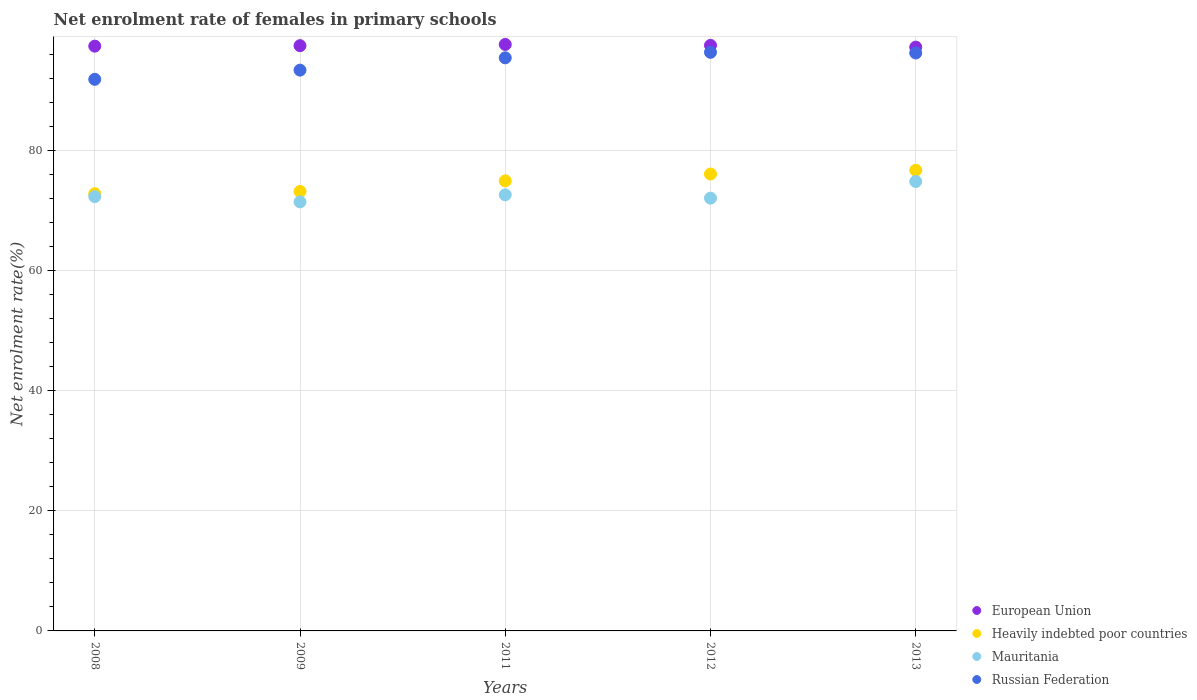How many different coloured dotlines are there?
Provide a short and direct response. 4. Is the number of dotlines equal to the number of legend labels?
Your response must be concise. Yes. What is the net enrolment rate of females in primary schools in Russian Federation in 2011?
Your answer should be very brief. 95.47. Across all years, what is the maximum net enrolment rate of females in primary schools in European Union?
Offer a terse response. 97.7. Across all years, what is the minimum net enrolment rate of females in primary schools in Mauritania?
Offer a very short reply. 71.47. In which year was the net enrolment rate of females in primary schools in European Union maximum?
Keep it short and to the point. 2011. In which year was the net enrolment rate of females in primary schools in Russian Federation minimum?
Your answer should be compact. 2008. What is the total net enrolment rate of females in primary schools in Heavily indebted poor countries in the graph?
Provide a succinct answer. 373.87. What is the difference between the net enrolment rate of females in primary schools in Russian Federation in 2009 and that in 2011?
Offer a very short reply. -2.05. What is the difference between the net enrolment rate of females in primary schools in Mauritania in 2011 and the net enrolment rate of females in primary schools in European Union in 2013?
Make the answer very short. -24.61. What is the average net enrolment rate of females in primary schools in Mauritania per year?
Offer a very short reply. 72.68. In the year 2013, what is the difference between the net enrolment rate of females in primary schools in European Union and net enrolment rate of females in primary schools in Heavily indebted poor countries?
Provide a succinct answer. 20.51. In how many years, is the net enrolment rate of females in primary schools in Mauritania greater than 8 %?
Give a very brief answer. 5. What is the ratio of the net enrolment rate of females in primary schools in Mauritania in 2011 to that in 2013?
Keep it short and to the point. 0.97. Is the difference between the net enrolment rate of females in primary schools in European Union in 2011 and 2012 greater than the difference between the net enrolment rate of females in primary schools in Heavily indebted poor countries in 2011 and 2012?
Your response must be concise. Yes. What is the difference between the highest and the second highest net enrolment rate of females in primary schools in Mauritania?
Provide a succinct answer. 2.22. What is the difference between the highest and the lowest net enrolment rate of females in primary schools in European Union?
Keep it short and to the point. 0.44. Is it the case that in every year, the sum of the net enrolment rate of females in primary schools in Heavily indebted poor countries and net enrolment rate of females in primary schools in European Union  is greater than the sum of net enrolment rate of females in primary schools in Russian Federation and net enrolment rate of females in primary schools in Mauritania?
Provide a short and direct response. Yes. Is it the case that in every year, the sum of the net enrolment rate of females in primary schools in Mauritania and net enrolment rate of females in primary schools in Heavily indebted poor countries  is greater than the net enrolment rate of females in primary schools in Russian Federation?
Provide a short and direct response. Yes. Is the net enrolment rate of females in primary schools in Mauritania strictly greater than the net enrolment rate of females in primary schools in Russian Federation over the years?
Your response must be concise. No. How many dotlines are there?
Your answer should be very brief. 4. What is the difference between two consecutive major ticks on the Y-axis?
Keep it short and to the point. 20. How many legend labels are there?
Your answer should be compact. 4. How are the legend labels stacked?
Your answer should be compact. Vertical. What is the title of the graph?
Your answer should be compact. Net enrolment rate of females in primary schools. Does "Switzerland" appear as one of the legend labels in the graph?
Offer a very short reply. No. What is the label or title of the Y-axis?
Provide a short and direct response. Net enrolment rate(%). What is the Net enrolment rate(%) in European Union in 2008?
Your response must be concise. 97.41. What is the Net enrolment rate(%) in Heavily indebted poor countries in 2008?
Provide a succinct answer. 72.83. What is the Net enrolment rate(%) in Mauritania in 2008?
Your answer should be compact. 72.34. What is the Net enrolment rate(%) in Russian Federation in 2008?
Give a very brief answer. 91.89. What is the Net enrolment rate(%) in European Union in 2009?
Your answer should be compact. 97.49. What is the Net enrolment rate(%) in Heavily indebted poor countries in 2009?
Give a very brief answer. 73.21. What is the Net enrolment rate(%) in Mauritania in 2009?
Make the answer very short. 71.47. What is the Net enrolment rate(%) in Russian Federation in 2009?
Your answer should be compact. 93.42. What is the Net enrolment rate(%) of European Union in 2011?
Offer a very short reply. 97.7. What is the Net enrolment rate(%) in Heavily indebted poor countries in 2011?
Offer a very short reply. 74.97. What is the Net enrolment rate(%) in Mauritania in 2011?
Provide a short and direct response. 72.65. What is the Net enrolment rate(%) of Russian Federation in 2011?
Provide a short and direct response. 95.47. What is the Net enrolment rate(%) of European Union in 2012?
Your answer should be compact. 97.54. What is the Net enrolment rate(%) of Heavily indebted poor countries in 2012?
Keep it short and to the point. 76.11. What is the Net enrolment rate(%) of Mauritania in 2012?
Provide a short and direct response. 72.09. What is the Net enrolment rate(%) in Russian Federation in 2012?
Make the answer very short. 96.38. What is the Net enrolment rate(%) in European Union in 2013?
Give a very brief answer. 97.25. What is the Net enrolment rate(%) in Heavily indebted poor countries in 2013?
Give a very brief answer. 76.74. What is the Net enrolment rate(%) of Mauritania in 2013?
Make the answer very short. 74.87. What is the Net enrolment rate(%) of Russian Federation in 2013?
Keep it short and to the point. 96.27. Across all years, what is the maximum Net enrolment rate(%) of European Union?
Make the answer very short. 97.7. Across all years, what is the maximum Net enrolment rate(%) of Heavily indebted poor countries?
Offer a very short reply. 76.74. Across all years, what is the maximum Net enrolment rate(%) of Mauritania?
Your answer should be compact. 74.87. Across all years, what is the maximum Net enrolment rate(%) of Russian Federation?
Offer a terse response. 96.38. Across all years, what is the minimum Net enrolment rate(%) of European Union?
Your answer should be compact. 97.25. Across all years, what is the minimum Net enrolment rate(%) of Heavily indebted poor countries?
Make the answer very short. 72.83. Across all years, what is the minimum Net enrolment rate(%) of Mauritania?
Your answer should be very brief. 71.47. Across all years, what is the minimum Net enrolment rate(%) in Russian Federation?
Offer a very short reply. 91.89. What is the total Net enrolment rate(%) of European Union in the graph?
Your answer should be very brief. 487.4. What is the total Net enrolment rate(%) in Heavily indebted poor countries in the graph?
Provide a short and direct response. 373.87. What is the total Net enrolment rate(%) of Mauritania in the graph?
Keep it short and to the point. 363.42. What is the total Net enrolment rate(%) in Russian Federation in the graph?
Offer a terse response. 473.43. What is the difference between the Net enrolment rate(%) in European Union in 2008 and that in 2009?
Your answer should be compact. -0.08. What is the difference between the Net enrolment rate(%) in Heavily indebted poor countries in 2008 and that in 2009?
Provide a succinct answer. -0.37. What is the difference between the Net enrolment rate(%) in Mauritania in 2008 and that in 2009?
Offer a very short reply. 0.87. What is the difference between the Net enrolment rate(%) in Russian Federation in 2008 and that in 2009?
Provide a short and direct response. -1.53. What is the difference between the Net enrolment rate(%) in European Union in 2008 and that in 2011?
Provide a short and direct response. -0.28. What is the difference between the Net enrolment rate(%) of Heavily indebted poor countries in 2008 and that in 2011?
Provide a short and direct response. -2.14. What is the difference between the Net enrolment rate(%) of Mauritania in 2008 and that in 2011?
Your answer should be compact. -0.3. What is the difference between the Net enrolment rate(%) of Russian Federation in 2008 and that in 2011?
Make the answer very short. -3.58. What is the difference between the Net enrolment rate(%) of European Union in 2008 and that in 2012?
Make the answer very short. -0.13. What is the difference between the Net enrolment rate(%) in Heavily indebted poor countries in 2008 and that in 2012?
Offer a terse response. -3.28. What is the difference between the Net enrolment rate(%) in Mauritania in 2008 and that in 2012?
Offer a very short reply. 0.26. What is the difference between the Net enrolment rate(%) in Russian Federation in 2008 and that in 2012?
Your answer should be very brief. -4.5. What is the difference between the Net enrolment rate(%) in European Union in 2008 and that in 2013?
Your answer should be compact. 0.16. What is the difference between the Net enrolment rate(%) in Heavily indebted poor countries in 2008 and that in 2013?
Make the answer very short. -3.91. What is the difference between the Net enrolment rate(%) of Mauritania in 2008 and that in 2013?
Keep it short and to the point. -2.52. What is the difference between the Net enrolment rate(%) in Russian Federation in 2008 and that in 2013?
Provide a short and direct response. -4.38. What is the difference between the Net enrolment rate(%) in European Union in 2009 and that in 2011?
Your answer should be very brief. -0.2. What is the difference between the Net enrolment rate(%) of Heavily indebted poor countries in 2009 and that in 2011?
Your answer should be compact. -1.76. What is the difference between the Net enrolment rate(%) in Mauritania in 2009 and that in 2011?
Make the answer very short. -1.18. What is the difference between the Net enrolment rate(%) of Russian Federation in 2009 and that in 2011?
Your response must be concise. -2.05. What is the difference between the Net enrolment rate(%) in European Union in 2009 and that in 2012?
Make the answer very short. -0.05. What is the difference between the Net enrolment rate(%) of Heavily indebted poor countries in 2009 and that in 2012?
Your response must be concise. -2.91. What is the difference between the Net enrolment rate(%) in Mauritania in 2009 and that in 2012?
Your answer should be compact. -0.62. What is the difference between the Net enrolment rate(%) in Russian Federation in 2009 and that in 2012?
Your answer should be compact. -2.97. What is the difference between the Net enrolment rate(%) in European Union in 2009 and that in 2013?
Keep it short and to the point. 0.24. What is the difference between the Net enrolment rate(%) in Heavily indebted poor countries in 2009 and that in 2013?
Ensure brevity in your answer.  -3.53. What is the difference between the Net enrolment rate(%) in Mauritania in 2009 and that in 2013?
Offer a very short reply. -3.4. What is the difference between the Net enrolment rate(%) in Russian Federation in 2009 and that in 2013?
Provide a succinct answer. -2.85. What is the difference between the Net enrolment rate(%) of European Union in 2011 and that in 2012?
Give a very brief answer. 0.15. What is the difference between the Net enrolment rate(%) of Heavily indebted poor countries in 2011 and that in 2012?
Offer a very short reply. -1.14. What is the difference between the Net enrolment rate(%) of Mauritania in 2011 and that in 2012?
Ensure brevity in your answer.  0.56. What is the difference between the Net enrolment rate(%) of Russian Federation in 2011 and that in 2012?
Make the answer very short. -0.92. What is the difference between the Net enrolment rate(%) of European Union in 2011 and that in 2013?
Offer a terse response. 0.44. What is the difference between the Net enrolment rate(%) of Heavily indebted poor countries in 2011 and that in 2013?
Your answer should be very brief. -1.77. What is the difference between the Net enrolment rate(%) in Mauritania in 2011 and that in 2013?
Keep it short and to the point. -2.22. What is the difference between the Net enrolment rate(%) in Russian Federation in 2011 and that in 2013?
Your answer should be very brief. -0.8. What is the difference between the Net enrolment rate(%) of European Union in 2012 and that in 2013?
Provide a succinct answer. 0.29. What is the difference between the Net enrolment rate(%) of Heavily indebted poor countries in 2012 and that in 2013?
Keep it short and to the point. -0.63. What is the difference between the Net enrolment rate(%) of Mauritania in 2012 and that in 2013?
Ensure brevity in your answer.  -2.78. What is the difference between the Net enrolment rate(%) in Russian Federation in 2012 and that in 2013?
Provide a succinct answer. 0.11. What is the difference between the Net enrolment rate(%) in European Union in 2008 and the Net enrolment rate(%) in Heavily indebted poor countries in 2009?
Offer a very short reply. 24.21. What is the difference between the Net enrolment rate(%) of European Union in 2008 and the Net enrolment rate(%) of Mauritania in 2009?
Your answer should be compact. 25.94. What is the difference between the Net enrolment rate(%) of European Union in 2008 and the Net enrolment rate(%) of Russian Federation in 2009?
Give a very brief answer. 4. What is the difference between the Net enrolment rate(%) of Heavily indebted poor countries in 2008 and the Net enrolment rate(%) of Mauritania in 2009?
Ensure brevity in your answer.  1.36. What is the difference between the Net enrolment rate(%) of Heavily indebted poor countries in 2008 and the Net enrolment rate(%) of Russian Federation in 2009?
Make the answer very short. -20.59. What is the difference between the Net enrolment rate(%) in Mauritania in 2008 and the Net enrolment rate(%) in Russian Federation in 2009?
Your response must be concise. -21.07. What is the difference between the Net enrolment rate(%) of European Union in 2008 and the Net enrolment rate(%) of Heavily indebted poor countries in 2011?
Your answer should be very brief. 22.45. What is the difference between the Net enrolment rate(%) in European Union in 2008 and the Net enrolment rate(%) in Mauritania in 2011?
Offer a terse response. 24.77. What is the difference between the Net enrolment rate(%) in European Union in 2008 and the Net enrolment rate(%) in Russian Federation in 2011?
Give a very brief answer. 1.95. What is the difference between the Net enrolment rate(%) in Heavily indebted poor countries in 2008 and the Net enrolment rate(%) in Mauritania in 2011?
Make the answer very short. 0.19. What is the difference between the Net enrolment rate(%) in Heavily indebted poor countries in 2008 and the Net enrolment rate(%) in Russian Federation in 2011?
Provide a succinct answer. -22.63. What is the difference between the Net enrolment rate(%) in Mauritania in 2008 and the Net enrolment rate(%) in Russian Federation in 2011?
Provide a short and direct response. -23.12. What is the difference between the Net enrolment rate(%) in European Union in 2008 and the Net enrolment rate(%) in Heavily indebted poor countries in 2012?
Give a very brief answer. 21.3. What is the difference between the Net enrolment rate(%) in European Union in 2008 and the Net enrolment rate(%) in Mauritania in 2012?
Your response must be concise. 25.33. What is the difference between the Net enrolment rate(%) of European Union in 2008 and the Net enrolment rate(%) of Russian Federation in 2012?
Ensure brevity in your answer.  1.03. What is the difference between the Net enrolment rate(%) in Heavily indebted poor countries in 2008 and the Net enrolment rate(%) in Mauritania in 2012?
Your response must be concise. 0.74. What is the difference between the Net enrolment rate(%) of Heavily indebted poor countries in 2008 and the Net enrolment rate(%) of Russian Federation in 2012?
Make the answer very short. -23.55. What is the difference between the Net enrolment rate(%) in Mauritania in 2008 and the Net enrolment rate(%) in Russian Federation in 2012?
Give a very brief answer. -24.04. What is the difference between the Net enrolment rate(%) in European Union in 2008 and the Net enrolment rate(%) in Heavily indebted poor countries in 2013?
Provide a succinct answer. 20.67. What is the difference between the Net enrolment rate(%) in European Union in 2008 and the Net enrolment rate(%) in Mauritania in 2013?
Offer a very short reply. 22.55. What is the difference between the Net enrolment rate(%) in European Union in 2008 and the Net enrolment rate(%) in Russian Federation in 2013?
Your answer should be compact. 1.14. What is the difference between the Net enrolment rate(%) in Heavily indebted poor countries in 2008 and the Net enrolment rate(%) in Mauritania in 2013?
Keep it short and to the point. -2.03. What is the difference between the Net enrolment rate(%) in Heavily indebted poor countries in 2008 and the Net enrolment rate(%) in Russian Federation in 2013?
Provide a succinct answer. -23.44. What is the difference between the Net enrolment rate(%) in Mauritania in 2008 and the Net enrolment rate(%) in Russian Federation in 2013?
Make the answer very short. -23.93. What is the difference between the Net enrolment rate(%) of European Union in 2009 and the Net enrolment rate(%) of Heavily indebted poor countries in 2011?
Provide a short and direct response. 22.52. What is the difference between the Net enrolment rate(%) in European Union in 2009 and the Net enrolment rate(%) in Mauritania in 2011?
Your answer should be very brief. 24.85. What is the difference between the Net enrolment rate(%) in European Union in 2009 and the Net enrolment rate(%) in Russian Federation in 2011?
Make the answer very short. 2.03. What is the difference between the Net enrolment rate(%) in Heavily indebted poor countries in 2009 and the Net enrolment rate(%) in Mauritania in 2011?
Your answer should be compact. 0.56. What is the difference between the Net enrolment rate(%) of Heavily indebted poor countries in 2009 and the Net enrolment rate(%) of Russian Federation in 2011?
Your answer should be compact. -22.26. What is the difference between the Net enrolment rate(%) of Mauritania in 2009 and the Net enrolment rate(%) of Russian Federation in 2011?
Ensure brevity in your answer.  -24. What is the difference between the Net enrolment rate(%) of European Union in 2009 and the Net enrolment rate(%) of Heavily indebted poor countries in 2012?
Your response must be concise. 21.38. What is the difference between the Net enrolment rate(%) in European Union in 2009 and the Net enrolment rate(%) in Mauritania in 2012?
Give a very brief answer. 25.4. What is the difference between the Net enrolment rate(%) in European Union in 2009 and the Net enrolment rate(%) in Russian Federation in 2012?
Keep it short and to the point. 1.11. What is the difference between the Net enrolment rate(%) of Heavily indebted poor countries in 2009 and the Net enrolment rate(%) of Mauritania in 2012?
Your response must be concise. 1.12. What is the difference between the Net enrolment rate(%) in Heavily indebted poor countries in 2009 and the Net enrolment rate(%) in Russian Federation in 2012?
Give a very brief answer. -23.18. What is the difference between the Net enrolment rate(%) of Mauritania in 2009 and the Net enrolment rate(%) of Russian Federation in 2012?
Your response must be concise. -24.91. What is the difference between the Net enrolment rate(%) of European Union in 2009 and the Net enrolment rate(%) of Heavily indebted poor countries in 2013?
Your answer should be very brief. 20.75. What is the difference between the Net enrolment rate(%) of European Union in 2009 and the Net enrolment rate(%) of Mauritania in 2013?
Provide a short and direct response. 22.63. What is the difference between the Net enrolment rate(%) in European Union in 2009 and the Net enrolment rate(%) in Russian Federation in 2013?
Your response must be concise. 1.22. What is the difference between the Net enrolment rate(%) in Heavily indebted poor countries in 2009 and the Net enrolment rate(%) in Mauritania in 2013?
Your answer should be very brief. -1.66. What is the difference between the Net enrolment rate(%) in Heavily indebted poor countries in 2009 and the Net enrolment rate(%) in Russian Federation in 2013?
Your answer should be compact. -23.06. What is the difference between the Net enrolment rate(%) of Mauritania in 2009 and the Net enrolment rate(%) of Russian Federation in 2013?
Offer a terse response. -24.8. What is the difference between the Net enrolment rate(%) of European Union in 2011 and the Net enrolment rate(%) of Heavily indebted poor countries in 2012?
Make the answer very short. 21.58. What is the difference between the Net enrolment rate(%) in European Union in 2011 and the Net enrolment rate(%) in Mauritania in 2012?
Offer a very short reply. 25.61. What is the difference between the Net enrolment rate(%) in European Union in 2011 and the Net enrolment rate(%) in Russian Federation in 2012?
Offer a terse response. 1.31. What is the difference between the Net enrolment rate(%) of Heavily indebted poor countries in 2011 and the Net enrolment rate(%) of Mauritania in 2012?
Keep it short and to the point. 2.88. What is the difference between the Net enrolment rate(%) in Heavily indebted poor countries in 2011 and the Net enrolment rate(%) in Russian Federation in 2012?
Your answer should be compact. -21.41. What is the difference between the Net enrolment rate(%) of Mauritania in 2011 and the Net enrolment rate(%) of Russian Federation in 2012?
Your response must be concise. -23.74. What is the difference between the Net enrolment rate(%) of European Union in 2011 and the Net enrolment rate(%) of Heavily indebted poor countries in 2013?
Ensure brevity in your answer.  20.96. What is the difference between the Net enrolment rate(%) in European Union in 2011 and the Net enrolment rate(%) in Mauritania in 2013?
Your response must be concise. 22.83. What is the difference between the Net enrolment rate(%) in European Union in 2011 and the Net enrolment rate(%) in Russian Federation in 2013?
Give a very brief answer. 1.43. What is the difference between the Net enrolment rate(%) of Heavily indebted poor countries in 2011 and the Net enrolment rate(%) of Mauritania in 2013?
Your answer should be very brief. 0.1. What is the difference between the Net enrolment rate(%) in Heavily indebted poor countries in 2011 and the Net enrolment rate(%) in Russian Federation in 2013?
Provide a succinct answer. -21.3. What is the difference between the Net enrolment rate(%) of Mauritania in 2011 and the Net enrolment rate(%) of Russian Federation in 2013?
Ensure brevity in your answer.  -23.63. What is the difference between the Net enrolment rate(%) of European Union in 2012 and the Net enrolment rate(%) of Heavily indebted poor countries in 2013?
Keep it short and to the point. 20.8. What is the difference between the Net enrolment rate(%) in European Union in 2012 and the Net enrolment rate(%) in Mauritania in 2013?
Keep it short and to the point. 22.68. What is the difference between the Net enrolment rate(%) of European Union in 2012 and the Net enrolment rate(%) of Russian Federation in 2013?
Provide a short and direct response. 1.27. What is the difference between the Net enrolment rate(%) of Heavily indebted poor countries in 2012 and the Net enrolment rate(%) of Mauritania in 2013?
Keep it short and to the point. 1.25. What is the difference between the Net enrolment rate(%) of Heavily indebted poor countries in 2012 and the Net enrolment rate(%) of Russian Federation in 2013?
Provide a succinct answer. -20.16. What is the difference between the Net enrolment rate(%) of Mauritania in 2012 and the Net enrolment rate(%) of Russian Federation in 2013?
Give a very brief answer. -24.18. What is the average Net enrolment rate(%) in European Union per year?
Make the answer very short. 97.48. What is the average Net enrolment rate(%) of Heavily indebted poor countries per year?
Make the answer very short. 74.77. What is the average Net enrolment rate(%) in Mauritania per year?
Your answer should be very brief. 72.68. What is the average Net enrolment rate(%) of Russian Federation per year?
Your answer should be very brief. 94.69. In the year 2008, what is the difference between the Net enrolment rate(%) in European Union and Net enrolment rate(%) in Heavily indebted poor countries?
Provide a short and direct response. 24.58. In the year 2008, what is the difference between the Net enrolment rate(%) of European Union and Net enrolment rate(%) of Mauritania?
Keep it short and to the point. 25.07. In the year 2008, what is the difference between the Net enrolment rate(%) of European Union and Net enrolment rate(%) of Russian Federation?
Give a very brief answer. 5.53. In the year 2008, what is the difference between the Net enrolment rate(%) of Heavily indebted poor countries and Net enrolment rate(%) of Mauritania?
Keep it short and to the point. 0.49. In the year 2008, what is the difference between the Net enrolment rate(%) of Heavily indebted poor countries and Net enrolment rate(%) of Russian Federation?
Your answer should be very brief. -19.05. In the year 2008, what is the difference between the Net enrolment rate(%) in Mauritania and Net enrolment rate(%) in Russian Federation?
Provide a short and direct response. -19.54. In the year 2009, what is the difference between the Net enrolment rate(%) of European Union and Net enrolment rate(%) of Heavily indebted poor countries?
Provide a short and direct response. 24.29. In the year 2009, what is the difference between the Net enrolment rate(%) in European Union and Net enrolment rate(%) in Mauritania?
Keep it short and to the point. 26.02. In the year 2009, what is the difference between the Net enrolment rate(%) of European Union and Net enrolment rate(%) of Russian Federation?
Ensure brevity in your answer.  4.07. In the year 2009, what is the difference between the Net enrolment rate(%) in Heavily indebted poor countries and Net enrolment rate(%) in Mauritania?
Your answer should be very brief. 1.74. In the year 2009, what is the difference between the Net enrolment rate(%) of Heavily indebted poor countries and Net enrolment rate(%) of Russian Federation?
Make the answer very short. -20.21. In the year 2009, what is the difference between the Net enrolment rate(%) in Mauritania and Net enrolment rate(%) in Russian Federation?
Offer a very short reply. -21.95. In the year 2011, what is the difference between the Net enrolment rate(%) in European Union and Net enrolment rate(%) in Heavily indebted poor countries?
Keep it short and to the point. 22.73. In the year 2011, what is the difference between the Net enrolment rate(%) of European Union and Net enrolment rate(%) of Mauritania?
Provide a short and direct response. 25.05. In the year 2011, what is the difference between the Net enrolment rate(%) in European Union and Net enrolment rate(%) in Russian Federation?
Ensure brevity in your answer.  2.23. In the year 2011, what is the difference between the Net enrolment rate(%) of Heavily indebted poor countries and Net enrolment rate(%) of Mauritania?
Make the answer very short. 2.32. In the year 2011, what is the difference between the Net enrolment rate(%) of Heavily indebted poor countries and Net enrolment rate(%) of Russian Federation?
Your response must be concise. -20.5. In the year 2011, what is the difference between the Net enrolment rate(%) in Mauritania and Net enrolment rate(%) in Russian Federation?
Offer a terse response. -22.82. In the year 2012, what is the difference between the Net enrolment rate(%) in European Union and Net enrolment rate(%) in Heavily indebted poor countries?
Make the answer very short. 21.43. In the year 2012, what is the difference between the Net enrolment rate(%) in European Union and Net enrolment rate(%) in Mauritania?
Provide a short and direct response. 25.45. In the year 2012, what is the difference between the Net enrolment rate(%) in European Union and Net enrolment rate(%) in Russian Federation?
Offer a very short reply. 1.16. In the year 2012, what is the difference between the Net enrolment rate(%) of Heavily indebted poor countries and Net enrolment rate(%) of Mauritania?
Your answer should be compact. 4.02. In the year 2012, what is the difference between the Net enrolment rate(%) in Heavily indebted poor countries and Net enrolment rate(%) in Russian Federation?
Make the answer very short. -20.27. In the year 2012, what is the difference between the Net enrolment rate(%) of Mauritania and Net enrolment rate(%) of Russian Federation?
Provide a succinct answer. -24.3. In the year 2013, what is the difference between the Net enrolment rate(%) of European Union and Net enrolment rate(%) of Heavily indebted poor countries?
Ensure brevity in your answer.  20.51. In the year 2013, what is the difference between the Net enrolment rate(%) of European Union and Net enrolment rate(%) of Mauritania?
Offer a very short reply. 22.39. In the year 2013, what is the difference between the Net enrolment rate(%) of European Union and Net enrolment rate(%) of Russian Federation?
Give a very brief answer. 0.98. In the year 2013, what is the difference between the Net enrolment rate(%) in Heavily indebted poor countries and Net enrolment rate(%) in Mauritania?
Your answer should be compact. 1.87. In the year 2013, what is the difference between the Net enrolment rate(%) of Heavily indebted poor countries and Net enrolment rate(%) of Russian Federation?
Give a very brief answer. -19.53. In the year 2013, what is the difference between the Net enrolment rate(%) of Mauritania and Net enrolment rate(%) of Russian Federation?
Your response must be concise. -21.4. What is the ratio of the Net enrolment rate(%) in European Union in 2008 to that in 2009?
Make the answer very short. 1. What is the ratio of the Net enrolment rate(%) in Mauritania in 2008 to that in 2009?
Your response must be concise. 1.01. What is the ratio of the Net enrolment rate(%) in Russian Federation in 2008 to that in 2009?
Give a very brief answer. 0.98. What is the ratio of the Net enrolment rate(%) of European Union in 2008 to that in 2011?
Provide a succinct answer. 1. What is the ratio of the Net enrolment rate(%) of Heavily indebted poor countries in 2008 to that in 2011?
Give a very brief answer. 0.97. What is the ratio of the Net enrolment rate(%) of Mauritania in 2008 to that in 2011?
Provide a short and direct response. 1. What is the ratio of the Net enrolment rate(%) in Russian Federation in 2008 to that in 2011?
Your answer should be compact. 0.96. What is the ratio of the Net enrolment rate(%) in Heavily indebted poor countries in 2008 to that in 2012?
Your answer should be compact. 0.96. What is the ratio of the Net enrolment rate(%) in Mauritania in 2008 to that in 2012?
Your answer should be compact. 1. What is the ratio of the Net enrolment rate(%) of Russian Federation in 2008 to that in 2012?
Your response must be concise. 0.95. What is the ratio of the Net enrolment rate(%) of Heavily indebted poor countries in 2008 to that in 2013?
Offer a very short reply. 0.95. What is the ratio of the Net enrolment rate(%) in Mauritania in 2008 to that in 2013?
Your response must be concise. 0.97. What is the ratio of the Net enrolment rate(%) in Russian Federation in 2008 to that in 2013?
Provide a short and direct response. 0.95. What is the ratio of the Net enrolment rate(%) in European Union in 2009 to that in 2011?
Your answer should be compact. 1. What is the ratio of the Net enrolment rate(%) in Heavily indebted poor countries in 2009 to that in 2011?
Provide a succinct answer. 0.98. What is the ratio of the Net enrolment rate(%) in Mauritania in 2009 to that in 2011?
Make the answer very short. 0.98. What is the ratio of the Net enrolment rate(%) of Russian Federation in 2009 to that in 2011?
Your response must be concise. 0.98. What is the ratio of the Net enrolment rate(%) in Heavily indebted poor countries in 2009 to that in 2012?
Provide a succinct answer. 0.96. What is the ratio of the Net enrolment rate(%) of Mauritania in 2009 to that in 2012?
Give a very brief answer. 0.99. What is the ratio of the Net enrolment rate(%) in Russian Federation in 2009 to that in 2012?
Give a very brief answer. 0.97. What is the ratio of the Net enrolment rate(%) in European Union in 2009 to that in 2013?
Your answer should be compact. 1. What is the ratio of the Net enrolment rate(%) in Heavily indebted poor countries in 2009 to that in 2013?
Give a very brief answer. 0.95. What is the ratio of the Net enrolment rate(%) in Mauritania in 2009 to that in 2013?
Your answer should be compact. 0.95. What is the ratio of the Net enrolment rate(%) of Russian Federation in 2009 to that in 2013?
Provide a short and direct response. 0.97. What is the ratio of the Net enrolment rate(%) in European Union in 2011 to that in 2012?
Give a very brief answer. 1. What is the ratio of the Net enrolment rate(%) of Heavily indebted poor countries in 2011 to that in 2012?
Provide a succinct answer. 0.98. What is the ratio of the Net enrolment rate(%) of Mauritania in 2011 to that in 2012?
Your answer should be compact. 1.01. What is the ratio of the Net enrolment rate(%) in Heavily indebted poor countries in 2011 to that in 2013?
Ensure brevity in your answer.  0.98. What is the ratio of the Net enrolment rate(%) in Mauritania in 2011 to that in 2013?
Make the answer very short. 0.97. What is the ratio of the Net enrolment rate(%) in Russian Federation in 2011 to that in 2013?
Your answer should be very brief. 0.99. What is the ratio of the Net enrolment rate(%) of European Union in 2012 to that in 2013?
Keep it short and to the point. 1. What is the ratio of the Net enrolment rate(%) of Mauritania in 2012 to that in 2013?
Your answer should be very brief. 0.96. What is the ratio of the Net enrolment rate(%) of Russian Federation in 2012 to that in 2013?
Make the answer very short. 1. What is the difference between the highest and the second highest Net enrolment rate(%) of European Union?
Offer a very short reply. 0.15. What is the difference between the highest and the second highest Net enrolment rate(%) of Heavily indebted poor countries?
Offer a terse response. 0.63. What is the difference between the highest and the second highest Net enrolment rate(%) in Mauritania?
Make the answer very short. 2.22. What is the difference between the highest and the second highest Net enrolment rate(%) of Russian Federation?
Your answer should be compact. 0.11. What is the difference between the highest and the lowest Net enrolment rate(%) of European Union?
Provide a short and direct response. 0.44. What is the difference between the highest and the lowest Net enrolment rate(%) in Heavily indebted poor countries?
Provide a short and direct response. 3.91. What is the difference between the highest and the lowest Net enrolment rate(%) in Mauritania?
Offer a terse response. 3.4. What is the difference between the highest and the lowest Net enrolment rate(%) in Russian Federation?
Make the answer very short. 4.5. 